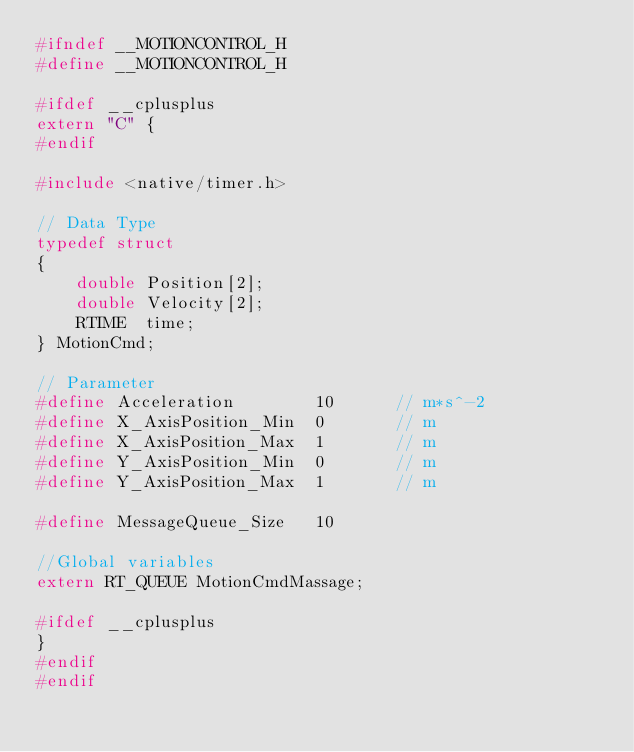<code> <loc_0><loc_0><loc_500><loc_500><_C_>#ifndef __MOTIONCONTROL_H
#define __MOTIONCONTROL_H

#ifdef __cplusplus
extern "C" { 
#endif

#include <native/timer.h>

// Data Type
typedef struct
{
    double Position[2];
    double Velocity[2];
	RTIME  time;
} MotionCmd;

// Parameter
#define Acceleration		10		// m*s^-2
#define X_AxisPosition_Min	0		// m
#define X_AxisPosition_Max	1		// m
#define Y_AxisPosition_Min	0		// m
#define Y_AxisPosition_Max	1		// m

#define MessageQueue_Size	10

//Global variables
extern RT_QUEUE MotionCmdMassage;

#ifdef __cplusplus 
}
#endif
#endif</code> 